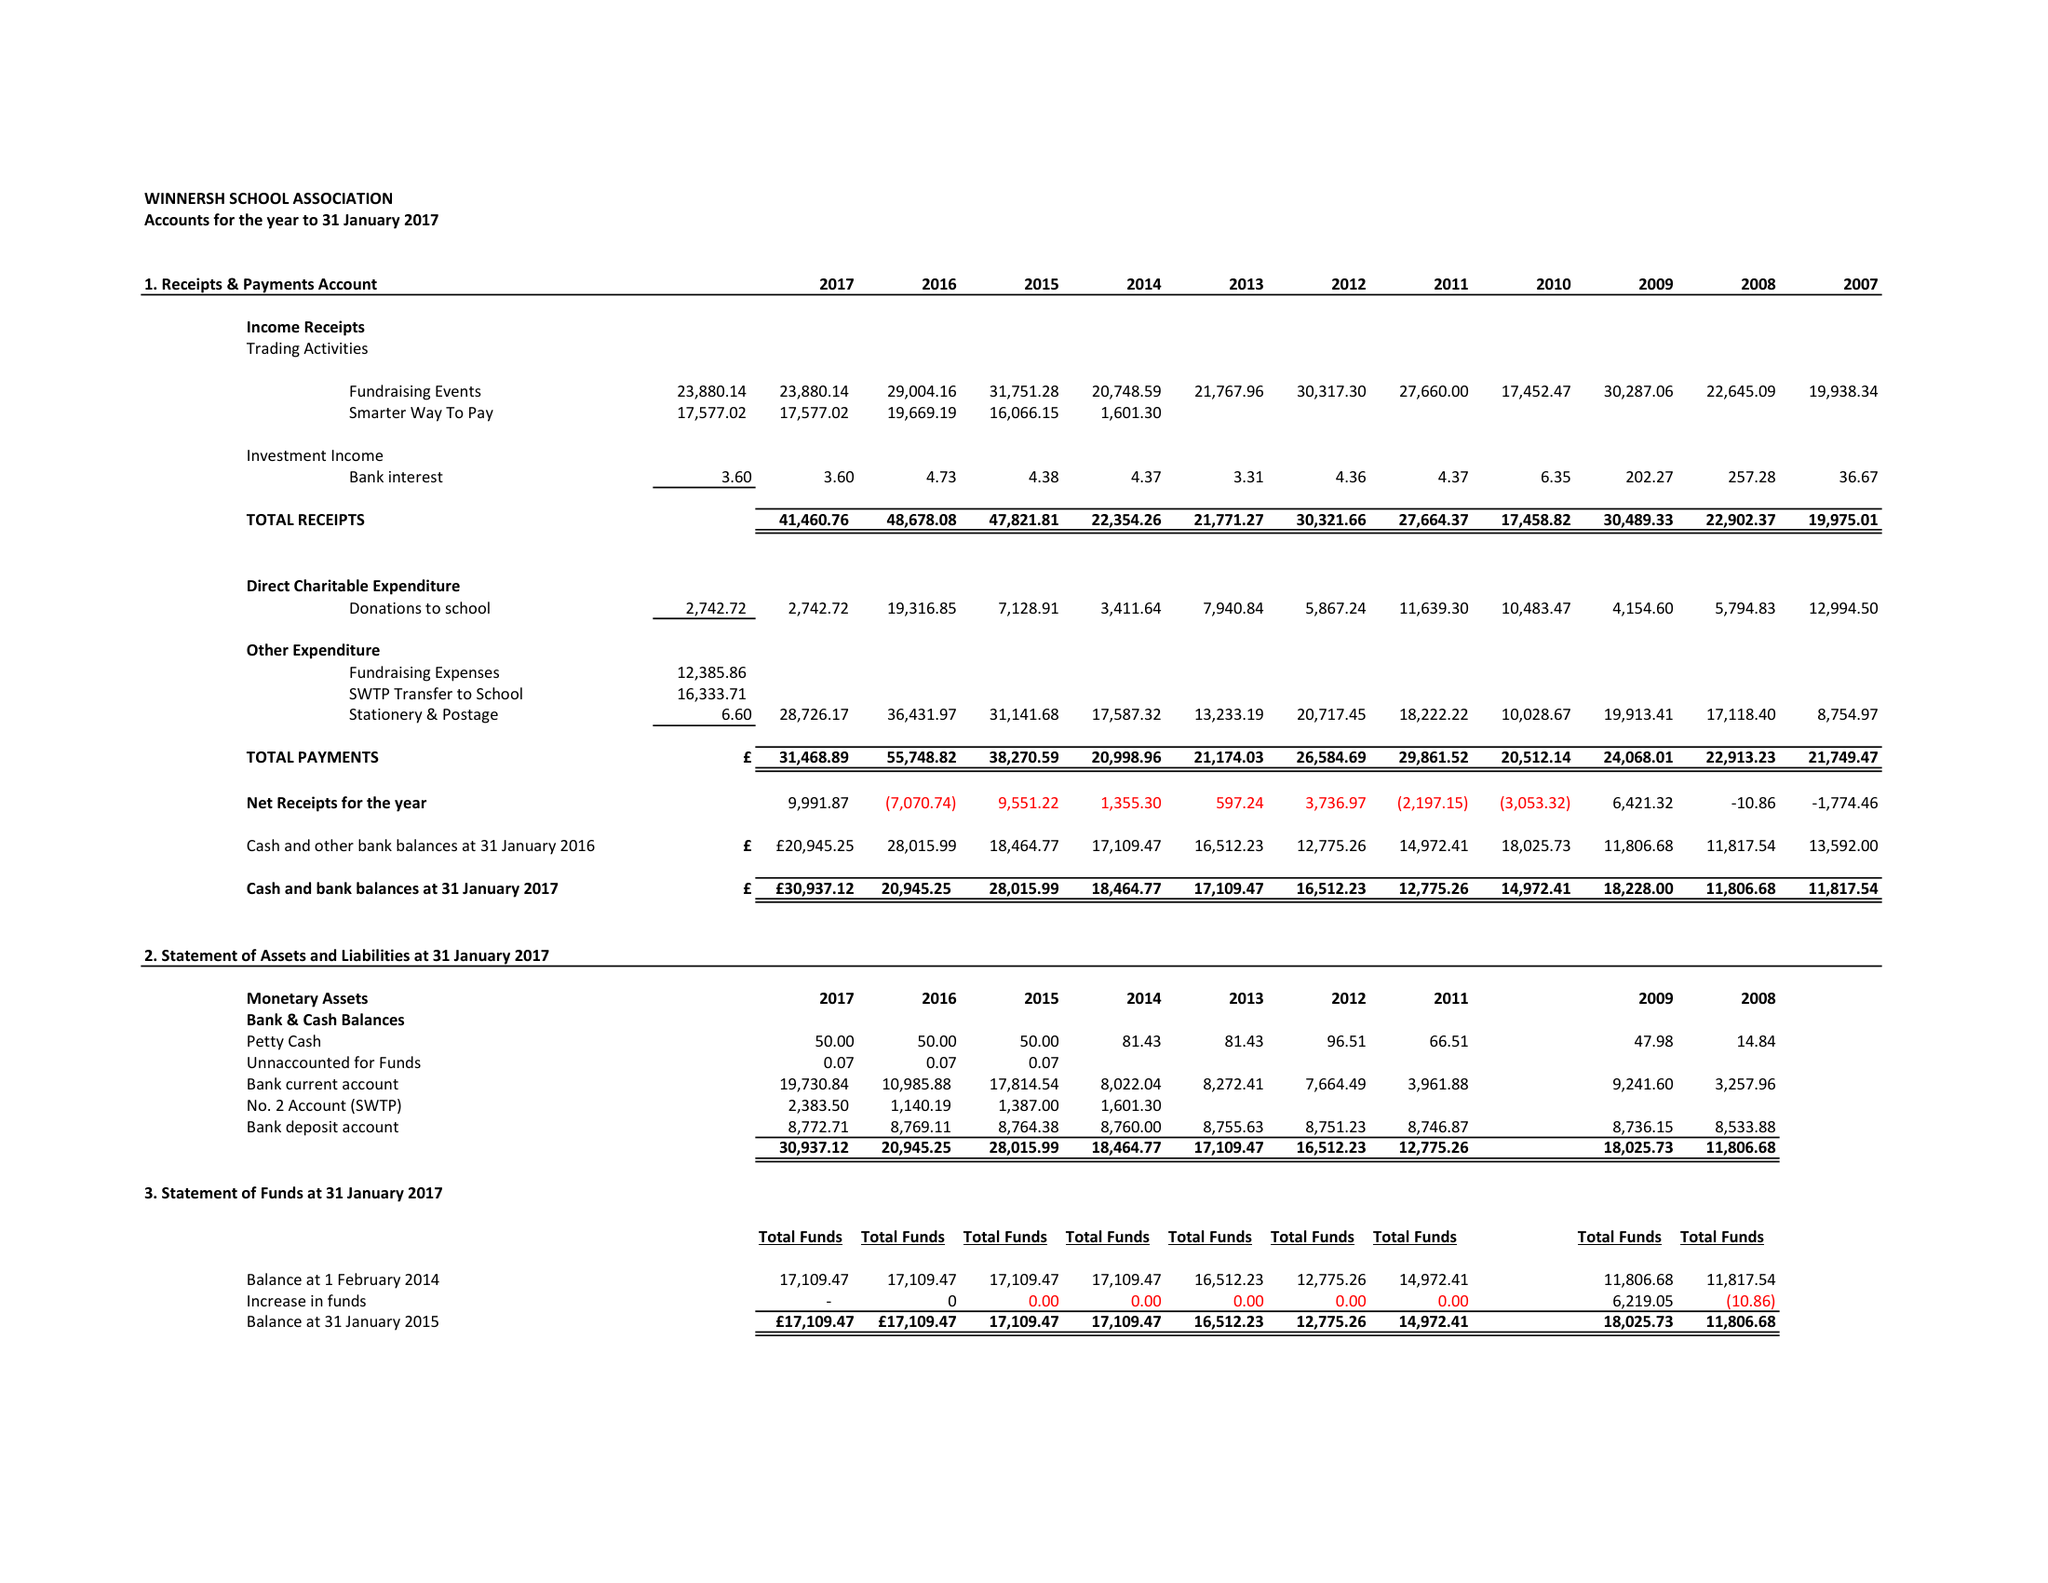What is the value for the address__postcode?
Answer the question using a single word or phrase. RG41 5LH 